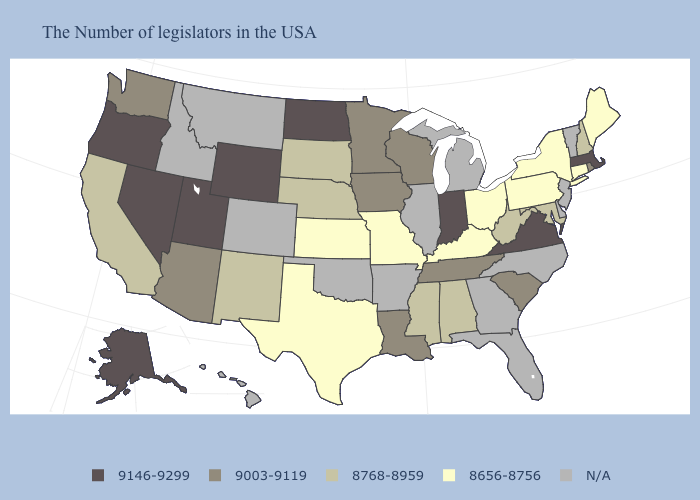Name the states that have a value in the range N/A?
Be succinct. Vermont, New Jersey, Delaware, North Carolina, Florida, Georgia, Michigan, Illinois, Arkansas, Oklahoma, Colorado, Montana, Idaho, Hawaii. What is the value of Nebraska?
Concise answer only. 8768-8959. What is the value of Missouri?
Be succinct. 8656-8756. What is the value of California?
Give a very brief answer. 8768-8959. Does Maine have the lowest value in the USA?
Quick response, please. Yes. What is the highest value in states that border Illinois?
Quick response, please. 9146-9299. Which states have the highest value in the USA?
Give a very brief answer. Massachusetts, Virginia, Indiana, North Dakota, Wyoming, Utah, Nevada, Oregon, Alaska. What is the lowest value in the USA?
Be succinct. 8656-8756. Among the states that border New York , does Massachusetts have the lowest value?
Be succinct. No. What is the value of Utah?
Be succinct. 9146-9299. What is the value of Michigan?
Give a very brief answer. N/A. Among the states that border Massachusetts , does Rhode Island have the highest value?
Answer briefly. Yes. Among the states that border Kentucky , which have the highest value?
Be succinct. Virginia, Indiana. What is the highest value in states that border Kansas?
Be succinct. 8768-8959. 